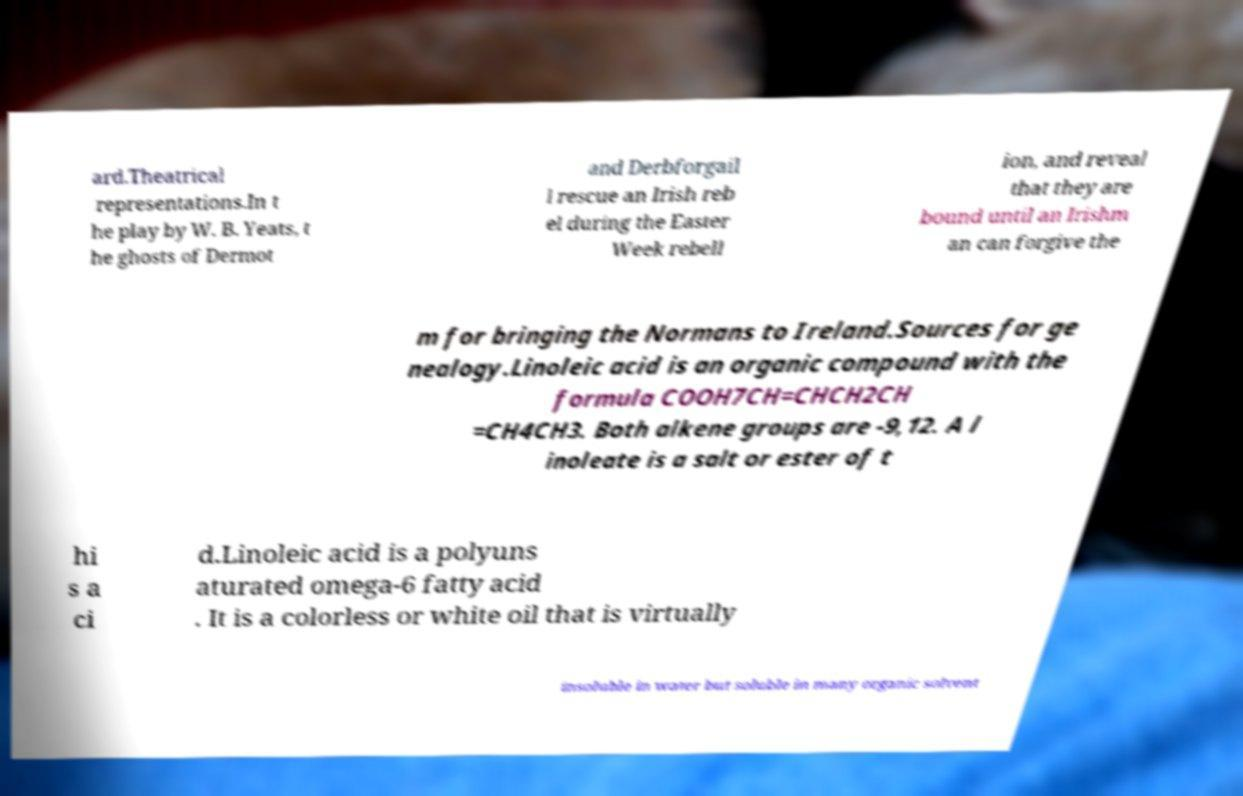There's text embedded in this image that I need extracted. Can you transcribe it verbatim? ard.Theatrical representations.In t he play by W. B. Yeats, t he ghosts of Dermot and Derbforgail l rescue an Irish reb el during the Easter Week rebell ion, and reveal that they are bound until an Irishm an can forgive the m for bringing the Normans to Ireland.Sources for ge nealogy.Linoleic acid is an organic compound with the formula COOH7CH=CHCH2CH =CH4CH3. Both alkene groups are -9,12. A l inoleate is a salt or ester of t hi s a ci d.Linoleic acid is a polyuns aturated omega-6 fatty acid . It is a colorless or white oil that is virtually insoluble in water but soluble in many organic solvent 